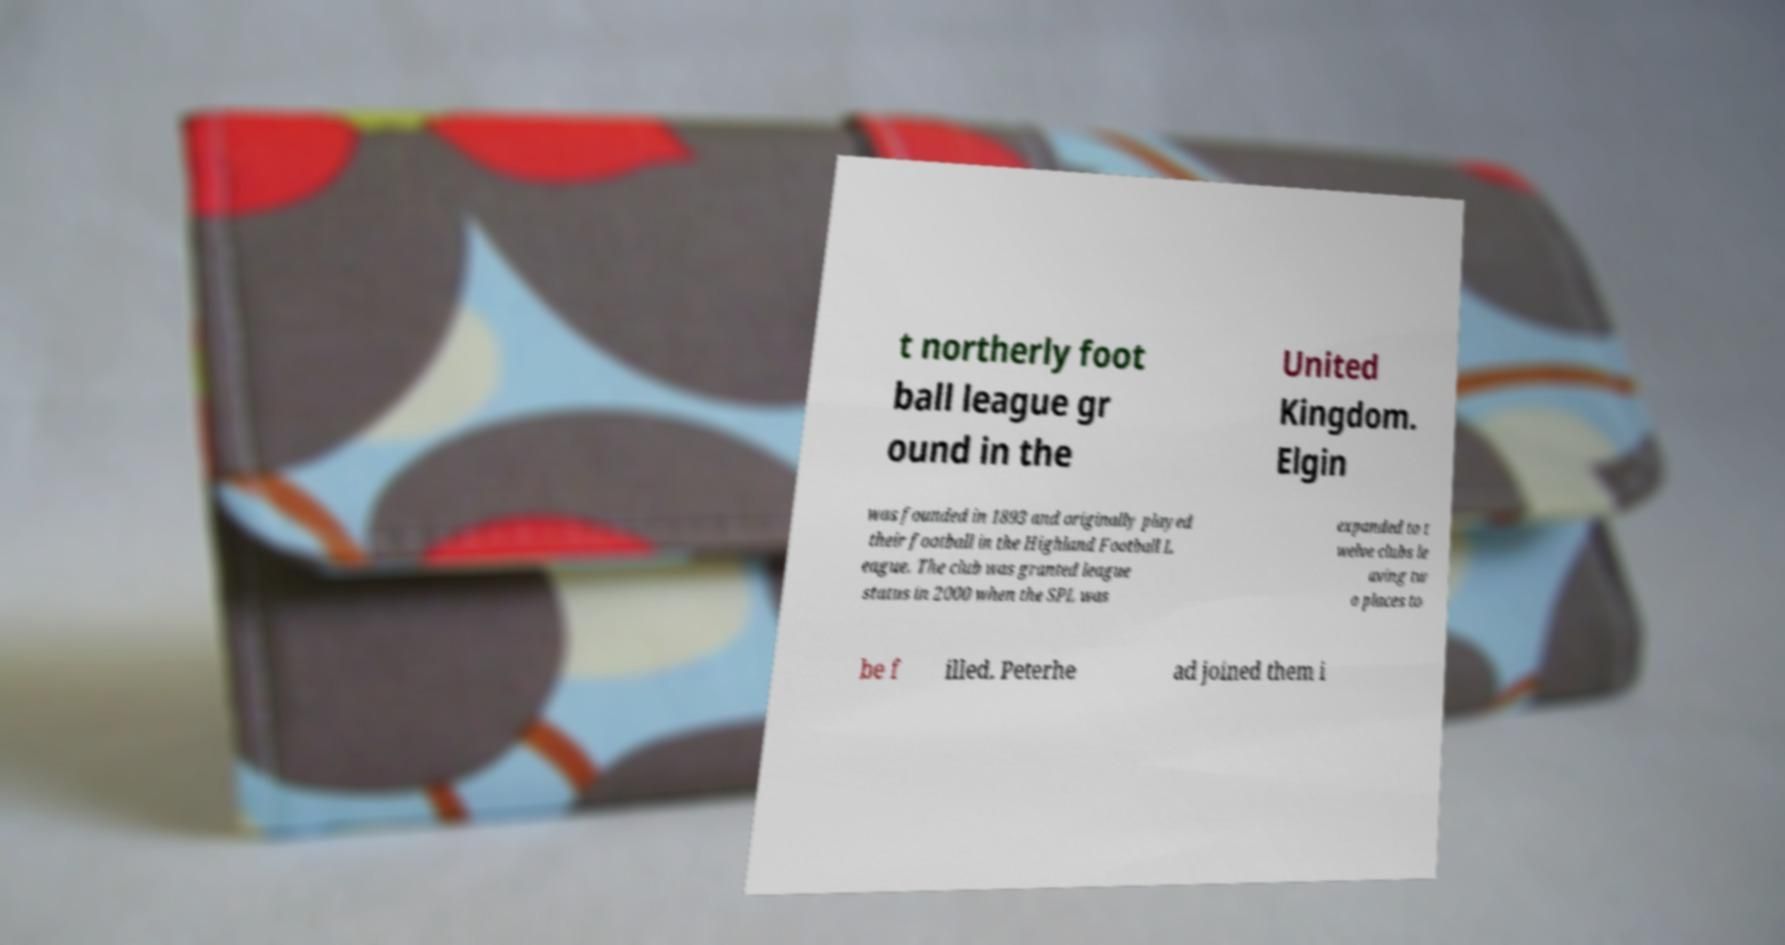For documentation purposes, I need the text within this image transcribed. Could you provide that? t northerly foot ball league gr ound in the United Kingdom. Elgin was founded in 1893 and originally played their football in the Highland Football L eague. The club was granted league status in 2000 when the SPL was expanded to t welve clubs le aving tw o places to be f illed. Peterhe ad joined them i 